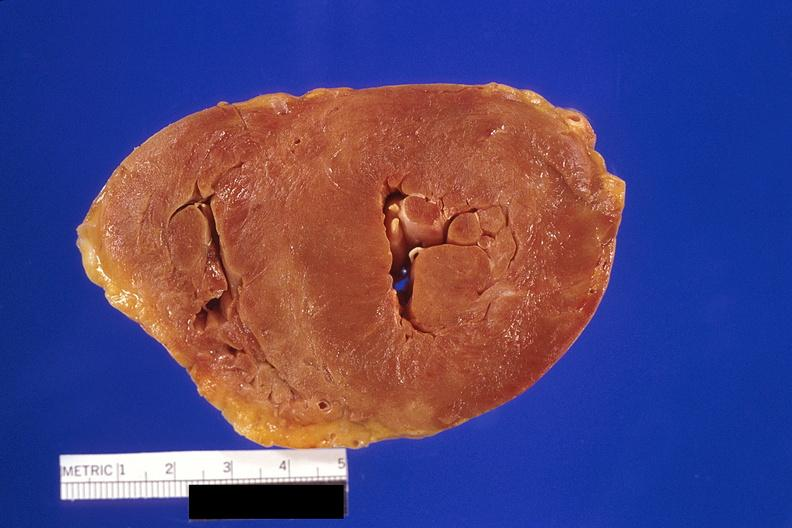what is present?
Answer the question using a single word or phrase. Cardiovascular 